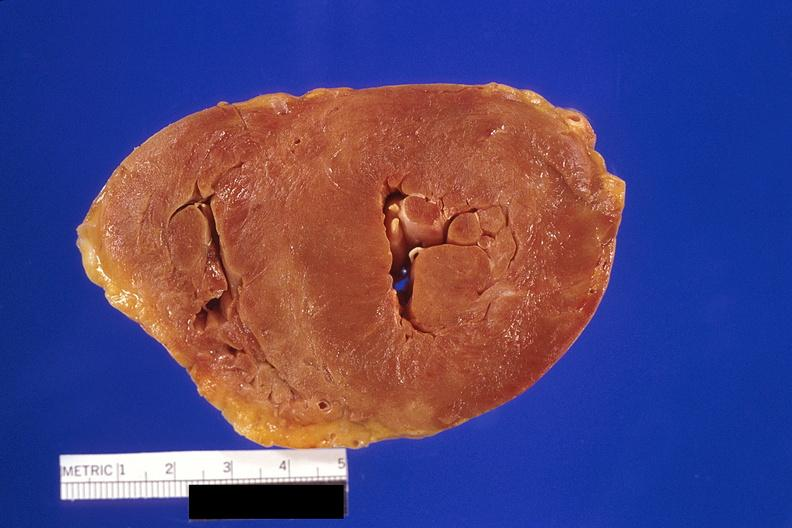what is present?
Answer the question using a single word or phrase. Cardiovascular 